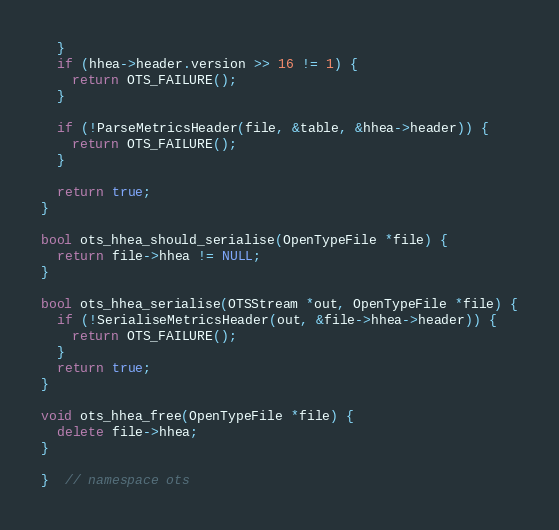Convert code to text. <code><loc_0><loc_0><loc_500><loc_500><_C++_>  }
  if (hhea->header.version >> 16 != 1) {
    return OTS_FAILURE();
  }

  if (!ParseMetricsHeader(file, &table, &hhea->header)) {
    return OTS_FAILURE();
  }

  return true;
}

bool ots_hhea_should_serialise(OpenTypeFile *file) {
  return file->hhea != NULL;
}

bool ots_hhea_serialise(OTSStream *out, OpenTypeFile *file) {
  if (!SerialiseMetricsHeader(out, &file->hhea->header)) {
    return OTS_FAILURE();
  }
  return true;
}

void ots_hhea_free(OpenTypeFile *file) {
  delete file->hhea;
}

}  // namespace ots
</code> 